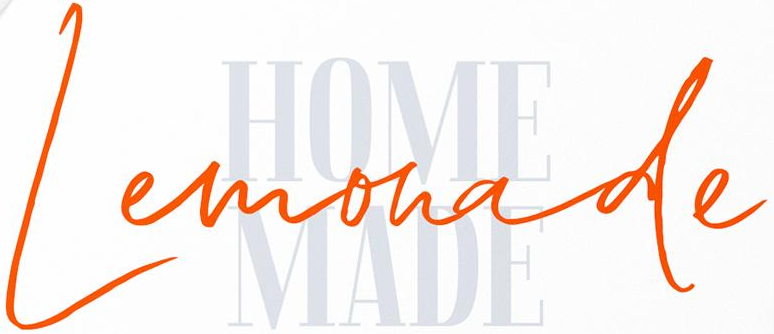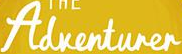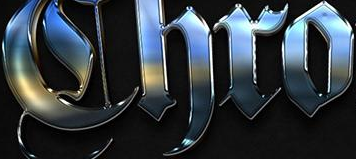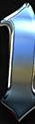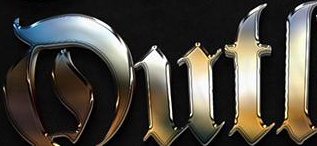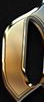What words are shown in these images in order, separated by a semicolon? Lemonade; Adventurer; Chro; #; Dutl; # 